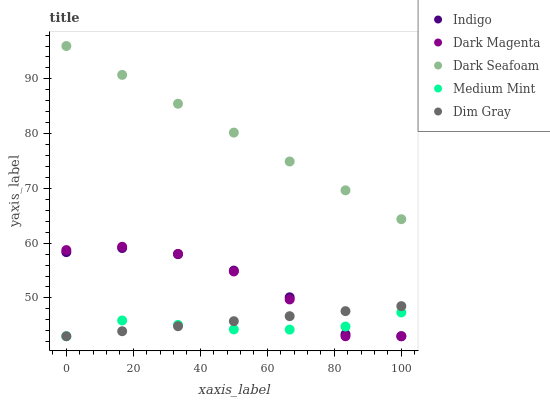Does Medium Mint have the minimum area under the curve?
Answer yes or no. Yes. Does Dark Seafoam have the maximum area under the curve?
Answer yes or no. Yes. Does Dim Gray have the minimum area under the curve?
Answer yes or no. No. Does Dim Gray have the maximum area under the curve?
Answer yes or no. No. Is Dark Seafoam the smoothest?
Answer yes or no. Yes. Is Dark Magenta the roughest?
Answer yes or no. Yes. Is Dim Gray the smoothest?
Answer yes or no. No. Is Dim Gray the roughest?
Answer yes or no. No. Does Medium Mint have the lowest value?
Answer yes or no. Yes. Does Dark Seafoam have the lowest value?
Answer yes or no. No. Does Dark Seafoam have the highest value?
Answer yes or no. Yes. Does Dim Gray have the highest value?
Answer yes or no. No. Is Dim Gray less than Dark Seafoam?
Answer yes or no. Yes. Is Dark Seafoam greater than Dark Magenta?
Answer yes or no. Yes. Does Medium Mint intersect Dark Magenta?
Answer yes or no. Yes. Is Medium Mint less than Dark Magenta?
Answer yes or no. No. Is Medium Mint greater than Dark Magenta?
Answer yes or no. No. Does Dim Gray intersect Dark Seafoam?
Answer yes or no. No. 